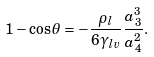Convert formula to latex. <formula><loc_0><loc_0><loc_500><loc_500>1 - \cos { \theta } = - \frac { \rho _ { l } } { 6 \gamma _ { l v } } \frac { a _ { 3 } ^ { 3 } } { a _ { 4 } ^ { 2 } } .</formula> 